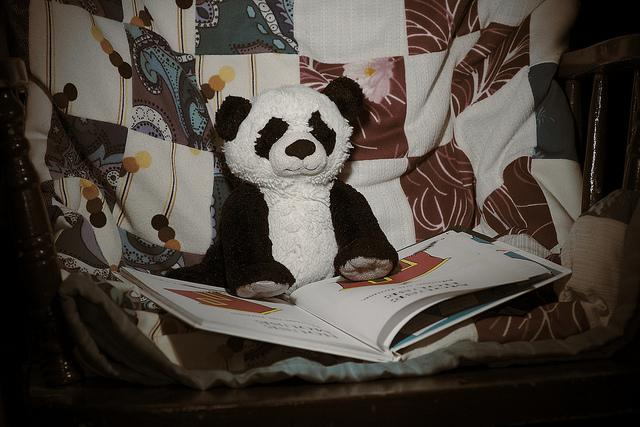Where do pandas come from?

Choices:
A) japan
B) china
C) mongolia
D) taiwan china 